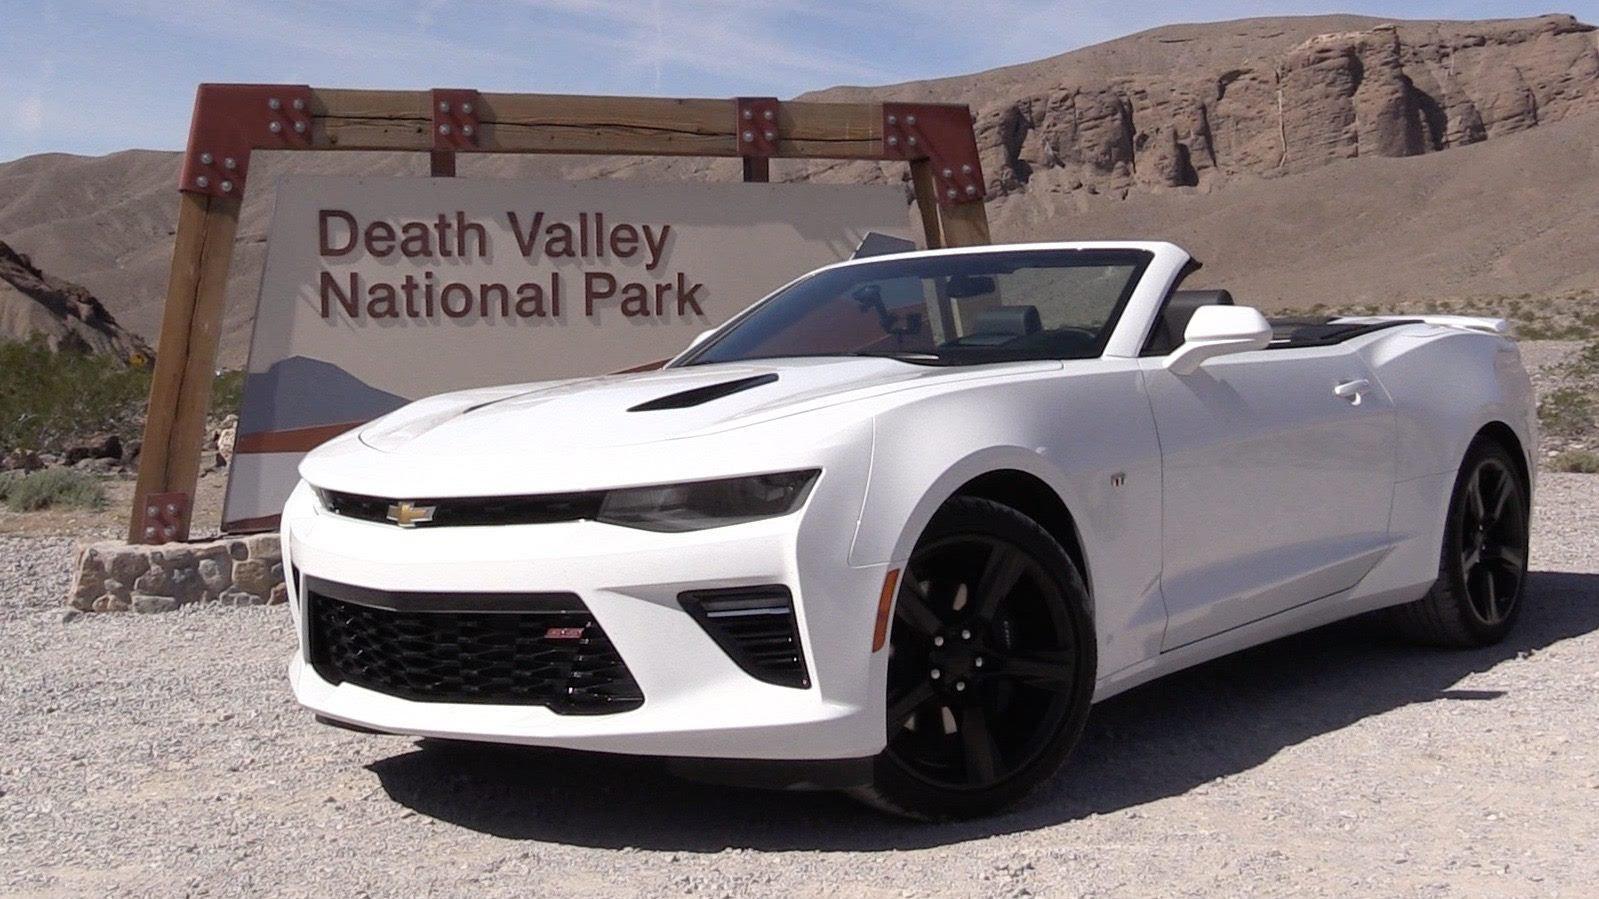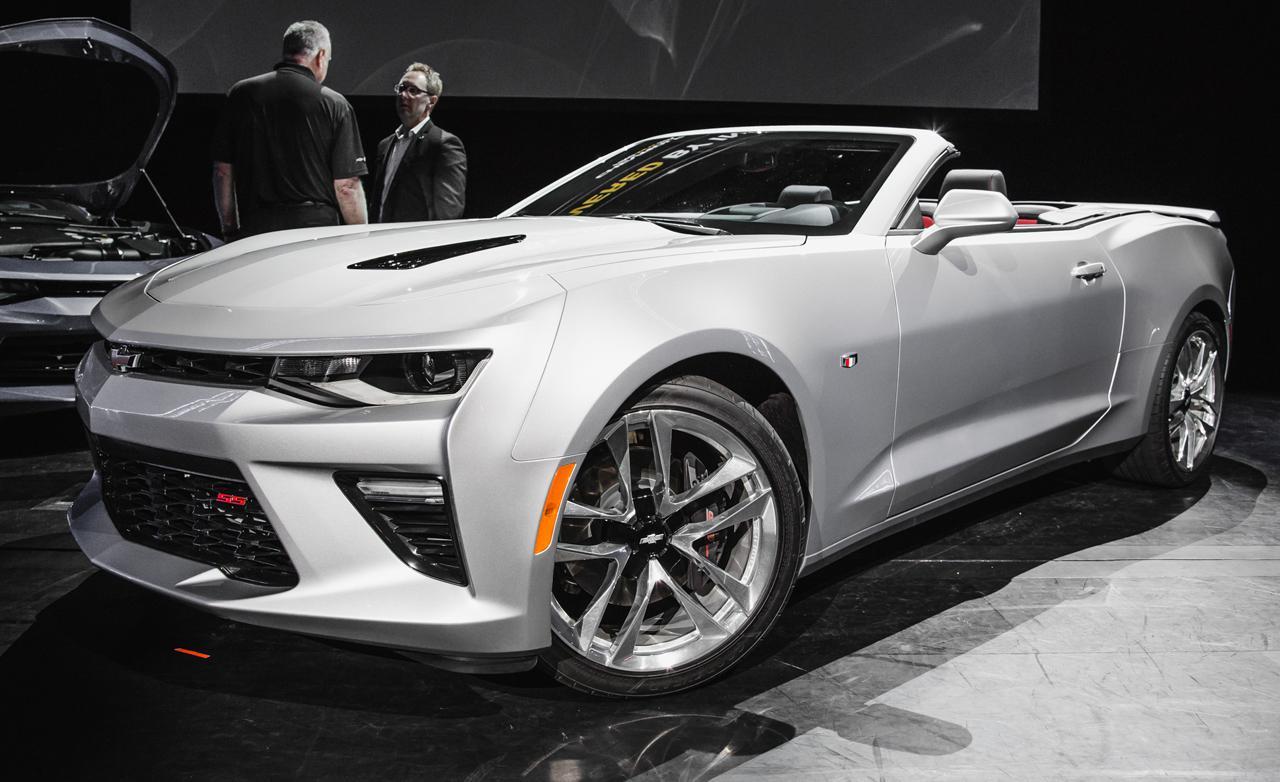The first image is the image on the left, the second image is the image on the right. Assess this claim about the two images: "The cars in both images are parked indoors.". Correct or not? Answer yes or no. No. The first image is the image on the left, the second image is the image on the right. Evaluate the accuracy of this statement regarding the images: "An image shows an angled white convertible with top down in an outdoor scene.". Is it true? Answer yes or no. Yes. 